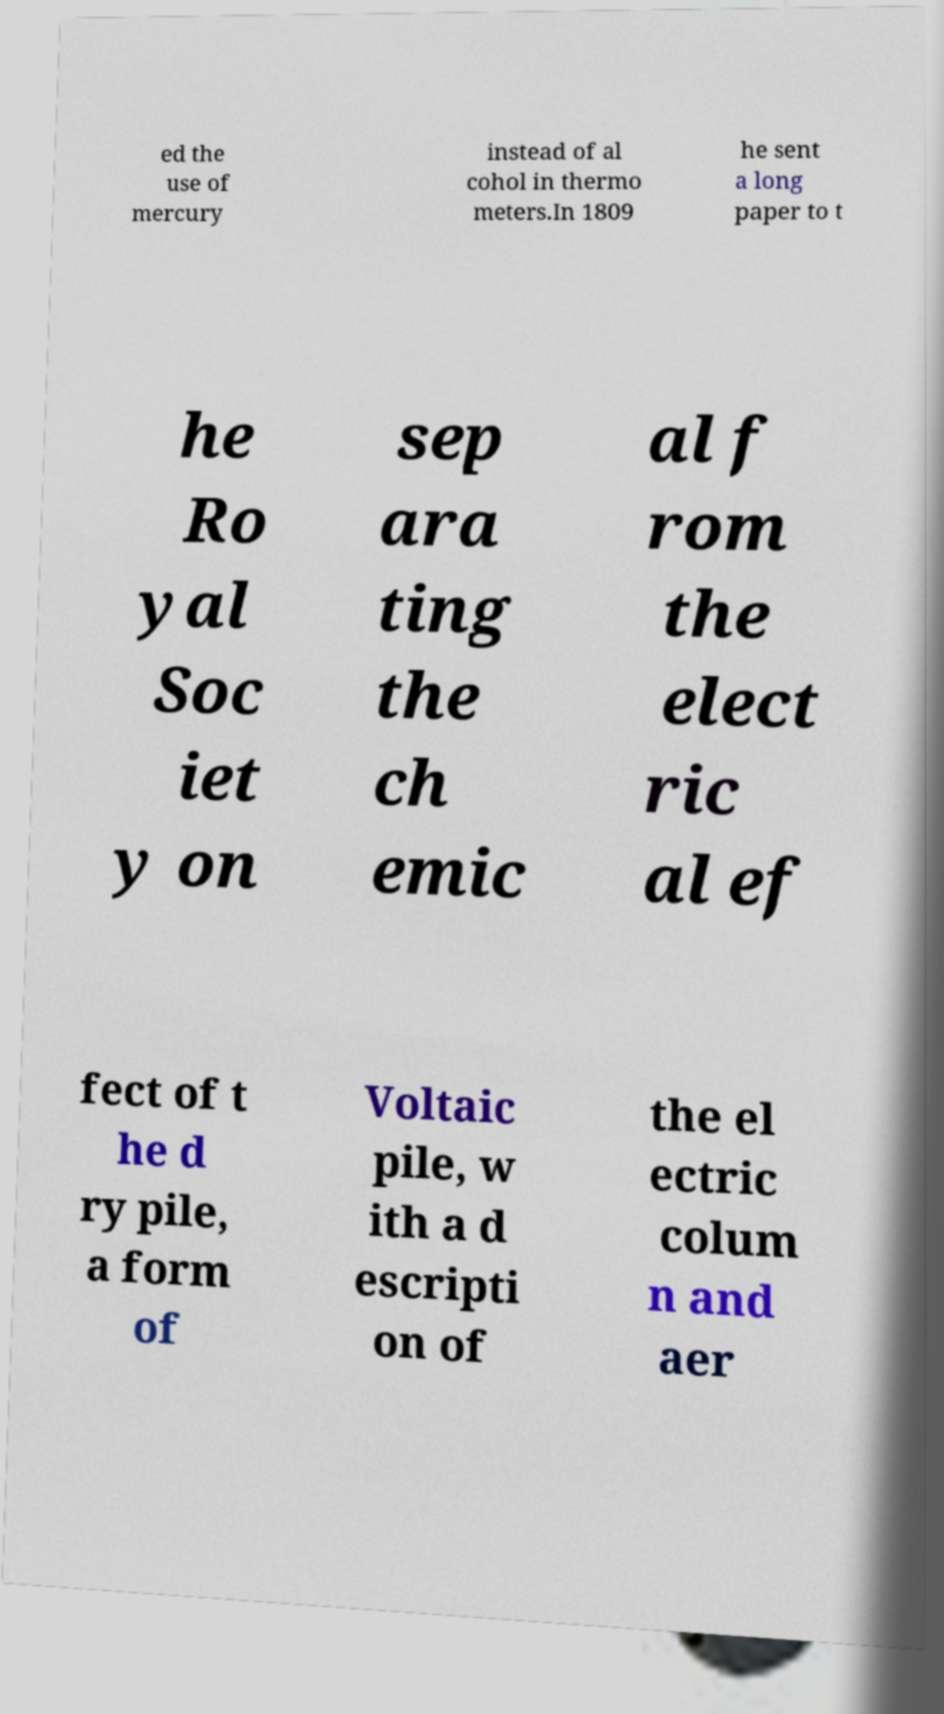Could you assist in decoding the text presented in this image and type it out clearly? ed the use of mercury instead of al cohol in thermo meters.In 1809 he sent a long paper to t he Ro yal Soc iet y on sep ara ting the ch emic al f rom the elect ric al ef fect of t he d ry pile, a form of Voltaic pile, w ith a d escripti on of the el ectric colum n and aer 